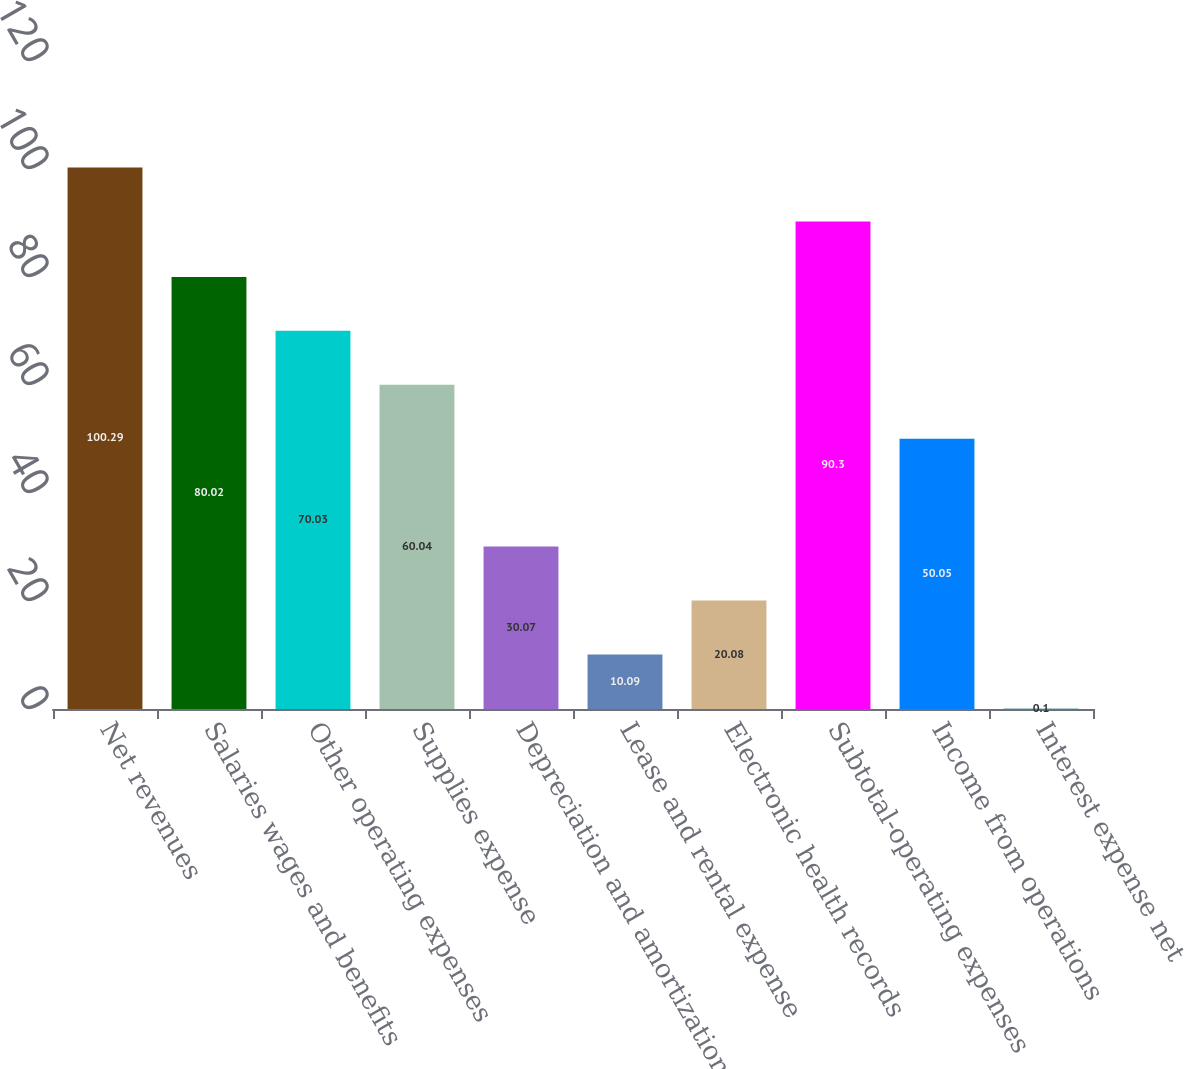Convert chart. <chart><loc_0><loc_0><loc_500><loc_500><bar_chart><fcel>Net revenues<fcel>Salaries wages and benefits<fcel>Other operating expenses<fcel>Supplies expense<fcel>Depreciation and amortization<fcel>Lease and rental expense<fcel>Electronic health records<fcel>Subtotal-operating expenses<fcel>Income from operations<fcel>Interest expense net<nl><fcel>100.29<fcel>80.02<fcel>70.03<fcel>60.04<fcel>30.07<fcel>10.09<fcel>20.08<fcel>90.3<fcel>50.05<fcel>0.1<nl></chart> 